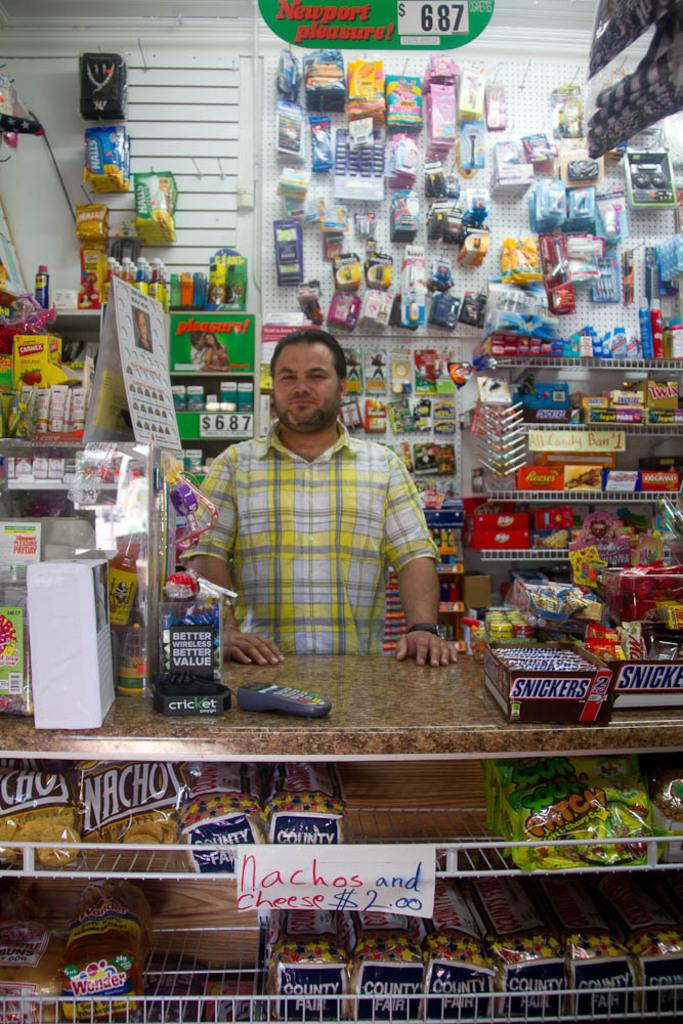Provide a one-sentence caption for the provided image. A store where Nachos and cheese are $2.00. 